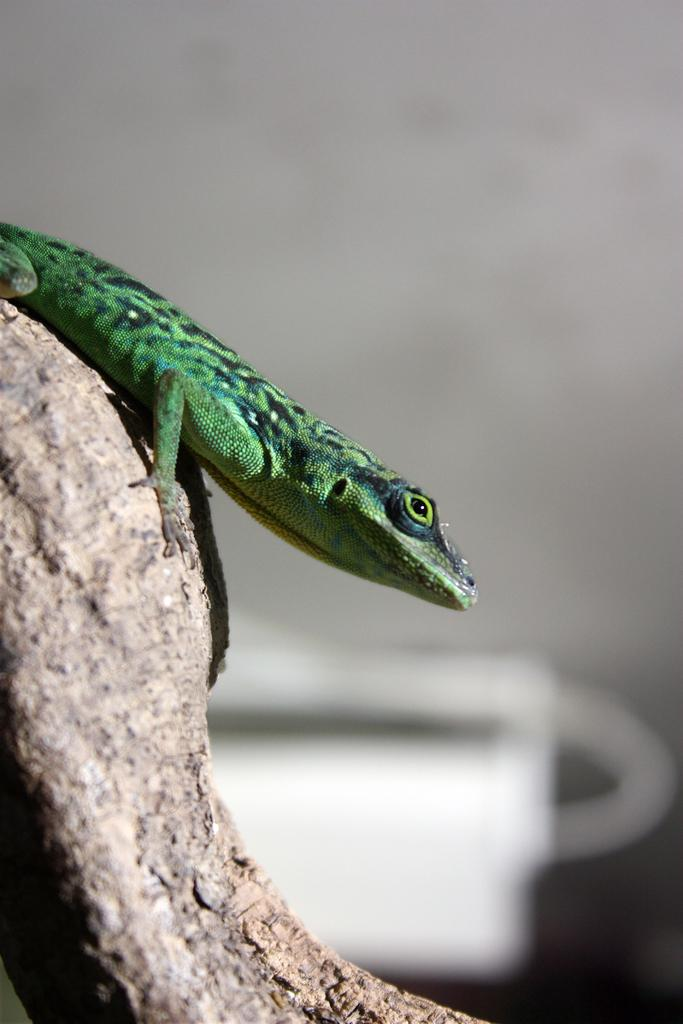What type of animal is in the image? There is a green color lizard in the image. Where is the lizard located? The lizard is sitting on a tree branch. Can you describe the background of the image? The background of the image is blurred. Did the cat cause the earthquake in the image? There is no cat or earthquake present in the image. What is the lizard's opinion on love in the image? The image does not provide any information about the lizard's opinion on love. 